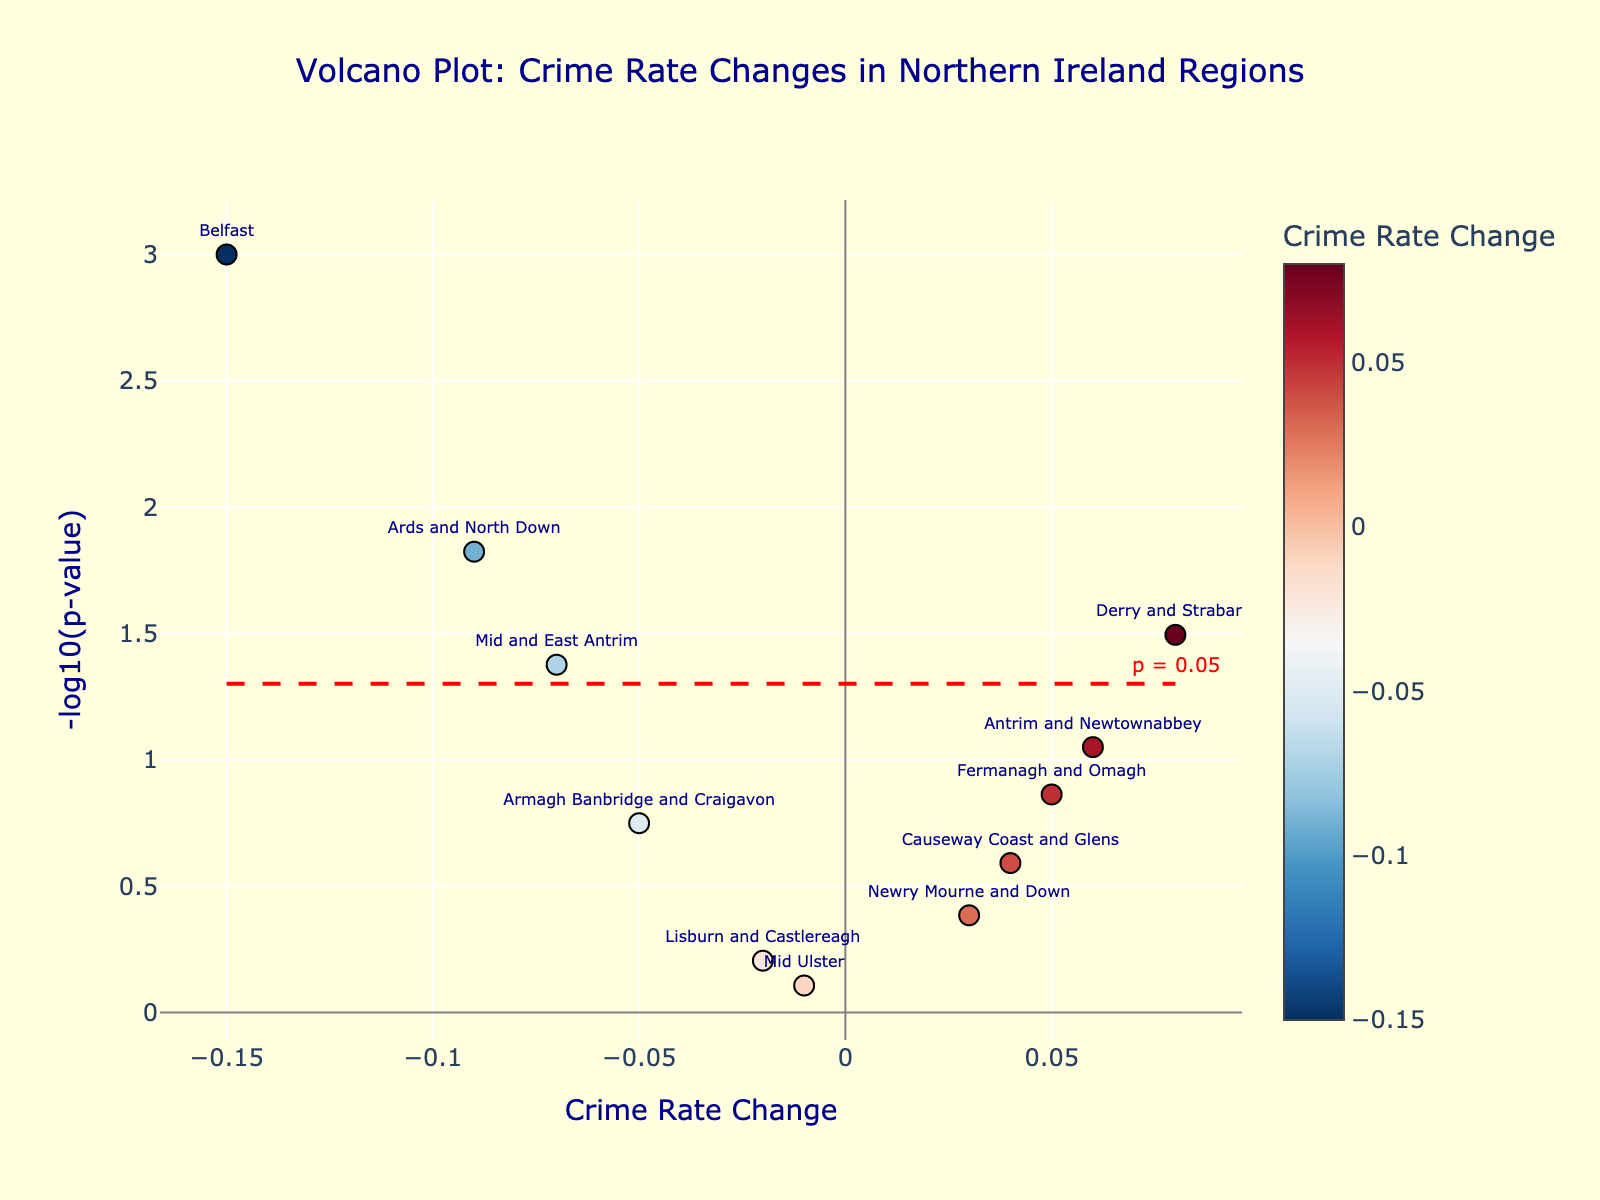Who experienced the largest decrease in crime rates? To determine the largest decrease in crime rates, look at the x-axis values and focus on the most negative value. The region with the largest negative crime rate change will be farthest to the left. In this case, it's Belfast with a change of -0.15.
Answer: Belfast Which region has the smallest p-value? The smallest p-value can be identified by looking at the highest point on the y-axis in the plot. The region closest to the y-axis value will have the smallest p-value. In this case, it's Belfast at 0.001.
Answer: Belfast Which regions have a statistically significant change in crime rates? To determine statistical significance, refer to the significance threshold line at -log10(p-value) = 1.3 (which corresponds to p = 0.05). Regions above this line are statistically significant. These regions are Belfast, Derry and Strabane, Ards and North Down, and Mid and East Antrim.
Answer: Belfast, Derry and Strabane, Ards and North Down, Mid and East Antrim What is the crime rate change for Armagh Banbridge and Craigavon? Find Armagh Banbridge and Craigavon on the plot and refer to its position on the x-axis. The crime rate change for Armagh Banbridge and Craigavon is -0.05.
Answer: -0.05 Are there more regions with increased crime rates or decreased crime rates? Count the number of regions to the left (negative change) and right (positive change) of the y-axis. There are more regions with a decrease in crime rates (Belfast, Armagh Banbridge and Craigavon, Ards and North Down, Mid and East Antrim) than those with an increase (Derry and Strabane, Newry Mourne and Down, Antrim and Newtownabbey, Causeway Coast and Glens, and Fermanagh and Omagh).
Answer: Decreased crime rates Which region has the highest crime rate change and is it statistically significant? Check for the highest x-axis value and observe if it is above the significance threshold line. Derry and Strabane have the highest crime rate change at 0.08, and it is above the red significance threshold line at -log10(p-value) = 1.3.
Answer: Derry and Strabane, Yes What is the -log10(p-value) for Lisburn and Castlereagh? Find Lisburn and Castlereagh on the plot and check its y-axis value. The -log10(p-value) for Lisburn and Castlereagh is close to 0.21.
Answer: ~0.21 Which regions have a crime rate change between -0.1 and 0? Locate regions within the x-axis range of -0.1 and 0. These regions are Mid and East Antrim, and Armagh Banbridge and Craigavon.
Answer: Mid and East Antrim, Armagh Banbridge and Craigavon What is the p-value threshold line indicating statistical significance? The threshold line is located at -log10(p-value) = 1.3 which corresponds to p = 0.05.
Answer: p = 0.05 